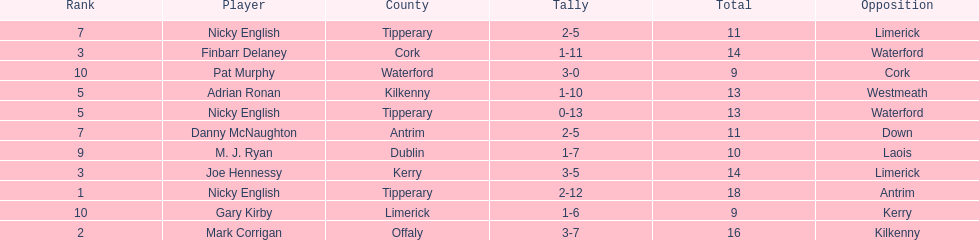What player got 10 total points in their game? M. J. Ryan. 